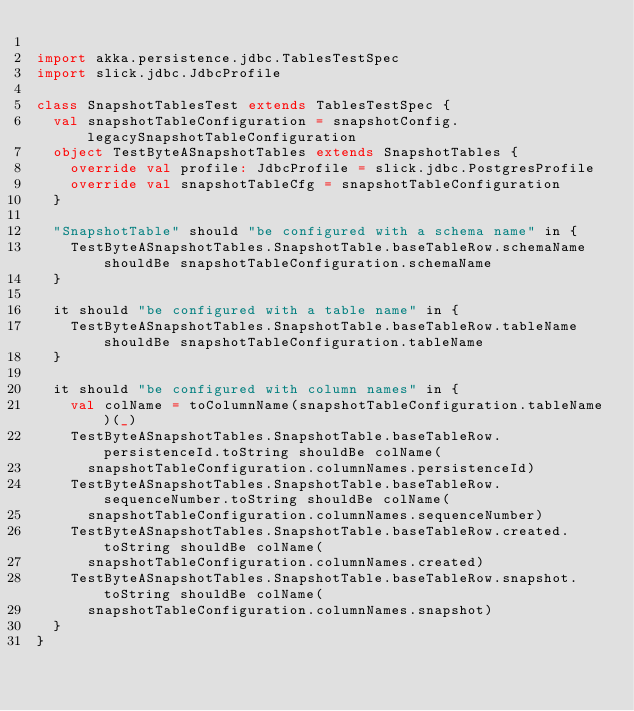<code> <loc_0><loc_0><loc_500><loc_500><_Scala_>
import akka.persistence.jdbc.TablesTestSpec
import slick.jdbc.JdbcProfile

class SnapshotTablesTest extends TablesTestSpec {
  val snapshotTableConfiguration = snapshotConfig.legacySnapshotTableConfiguration
  object TestByteASnapshotTables extends SnapshotTables {
    override val profile: JdbcProfile = slick.jdbc.PostgresProfile
    override val snapshotTableCfg = snapshotTableConfiguration
  }

  "SnapshotTable" should "be configured with a schema name" in {
    TestByteASnapshotTables.SnapshotTable.baseTableRow.schemaName shouldBe snapshotTableConfiguration.schemaName
  }

  it should "be configured with a table name" in {
    TestByteASnapshotTables.SnapshotTable.baseTableRow.tableName shouldBe snapshotTableConfiguration.tableName
  }

  it should "be configured with column names" in {
    val colName = toColumnName(snapshotTableConfiguration.tableName)(_)
    TestByteASnapshotTables.SnapshotTable.baseTableRow.persistenceId.toString shouldBe colName(
      snapshotTableConfiguration.columnNames.persistenceId)
    TestByteASnapshotTables.SnapshotTable.baseTableRow.sequenceNumber.toString shouldBe colName(
      snapshotTableConfiguration.columnNames.sequenceNumber)
    TestByteASnapshotTables.SnapshotTable.baseTableRow.created.toString shouldBe colName(
      snapshotTableConfiguration.columnNames.created)
    TestByteASnapshotTables.SnapshotTable.baseTableRow.snapshot.toString shouldBe colName(
      snapshotTableConfiguration.columnNames.snapshot)
  }
}
</code> 